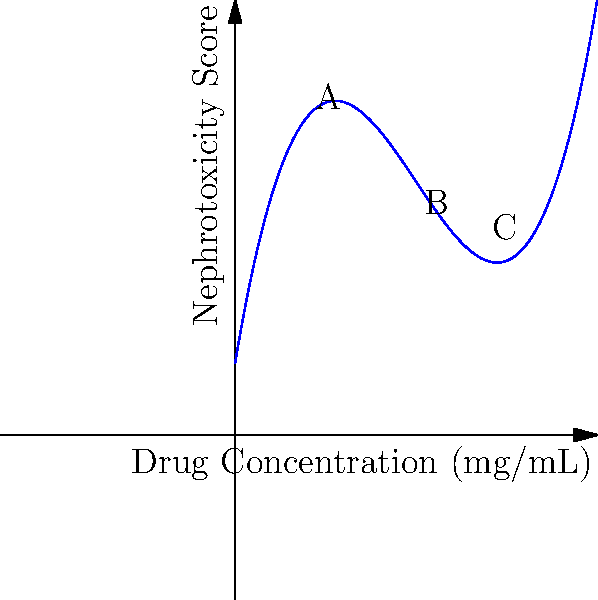The graph above shows the dose-response curve for a nephrotoxic drug. The curve is modeled by the polynomial function $f(x) = 0.1x^3 - 1.5x^2 + 6x + 2$, where $x$ is the drug concentration in mg/mL and $f(x)$ is the nephrotoxicity score. At which point (A, B, or C) does the drug exhibit the lowest nephrotoxicity, and what is the corresponding drug concentration? To find the point of lowest nephrotoxicity, we need to follow these steps:

1) Identify the x-coordinates (drug concentrations) for points A, B, and C:
   Point A: x ≈ 2 mg/mL
   Point B: x ≈ 5 mg/mL
   Point C: x ≈ 8 mg/mL

2) Calculate the nephrotoxicity score for each point using the given function:
   $f(x) = 0.1x^3 - 1.5x^2 + 6x + 2$

   For point A: $f(2) = 0.1(2^3) - 1.5(2^2) + 6(2) + 2 = 0.8 - 6 + 12 + 2 = 8.8$
   For point B: $f(5) = 0.1(5^3) - 1.5(5^2) + 6(5) + 2 = 12.5 - 37.5 + 30 + 2 = 7$
   For point C: $f(8) = 0.1(8^3) - 1.5(8^2) + 6(8) + 2 = 51.2 - 96 + 48 + 2 = 5.2$

3) Compare the nephrotoxicity scores:
   Point A: 8.8
   Point B: 7.0
   Point C: 5.2

4) The lowest nephrotoxicity score is at point C (5.2), corresponding to a drug concentration of 8 mg/mL.
Answer: Point C, 8 mg/mL 